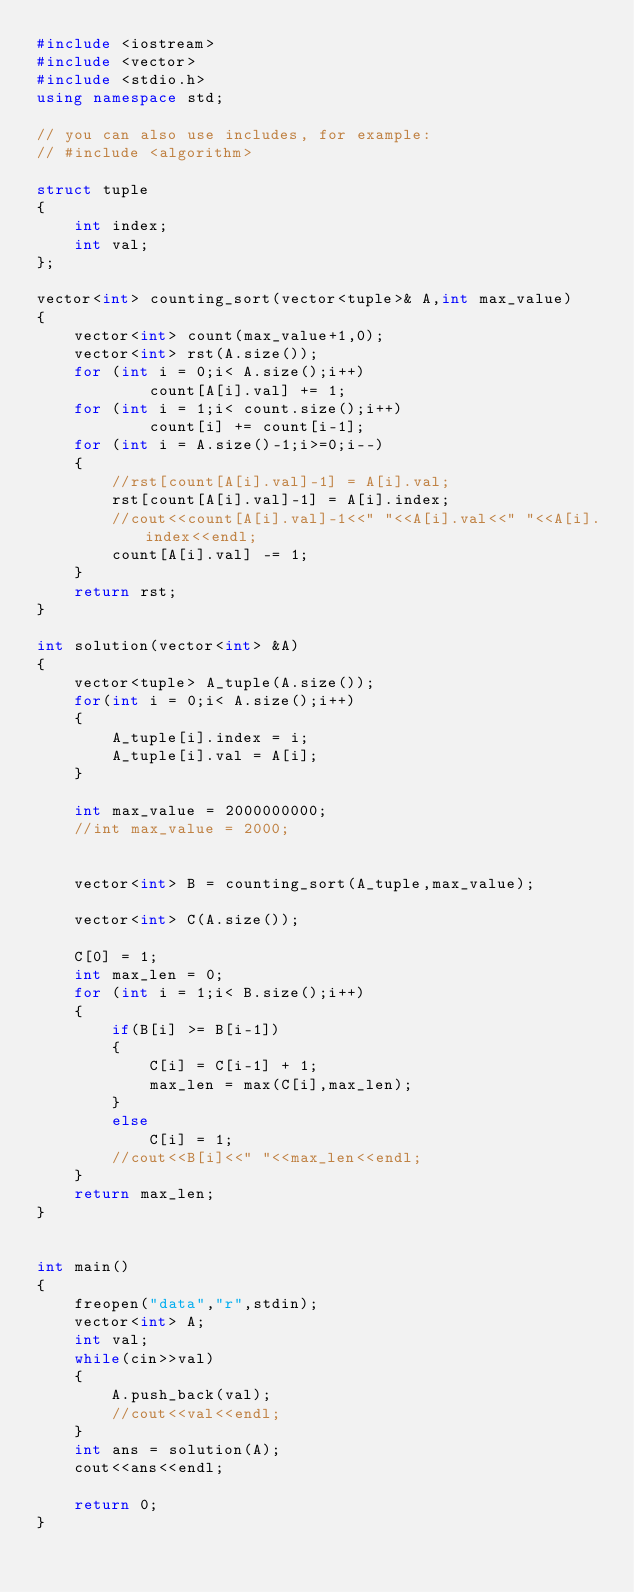<code> <loc_0><loc_0><loc_500><loc_500><_C++_>#include <iostream>
#include <vector>
#include <stdio.h>
using namespace std;

// you can also use includes, for example:
// #include <algorithm>

struct tuple
{
    int index;
    int val;
};

vector<int> counting_sort(vector<tuple>& A,int max_value)
{
    vector<int> count(max_value+1,0);
    vector<int> rst(A.size());
    for (int i = 0;i< A.size();i++)
            count[A[i].val] += 1;
    for (int i = 1;i< count.size();i++)
            count[i] += count[i-1];
    for (int i = A.size()-1;i>=0;i--)
    {
        //rst[count[A[i].val]-1] = A[i].val;
        rst[count[A[i].val]-1] = A[i].index;
        //cout<<count[A[i].val]-1<<" "<<A[i].val<<" "<<A[i].index<<endl;
        count[A[i].val] -= 1;
    }
    return rst;
}

int solution(vector<int> &A) 
{
    vector<tuple> A_tuple(A.size());
    for(int i = 0;i< A.size();i++)
    {
        A_tuple[i].index = i;
        A_tuple[i].val = A[i];
    }
    
    int max_value = 2000000000;
    //int max_value = 2000;
        

    vector<int> B = counting_sort(A_tuple,max_value);
    
    vector<int> C(A.size());

    C[0] = 1;
    int max_len = 0;
    for (int i = 1;i< B.size();i++)
    {
        if(B[i] >= B[i-1])
        {
            C[i] = C[i-1] + 1;
            max_len = max(C[i],max_len);
        }
        else
            C[i] = 1;
        //cout<<B[i]<<" "<<max_len<<endl;
    }
    return max_len;
}


int main()
{ 
    freopen("data","r",stdin);
    vector<int> A;
    int val;
    while(cin>>val)
    {
        A.push_back(val);
        //cout<<val<<endl;
    }
    int ans = solution(A);
    cout<<ans<<endl;

    return 0;
}
</code> 